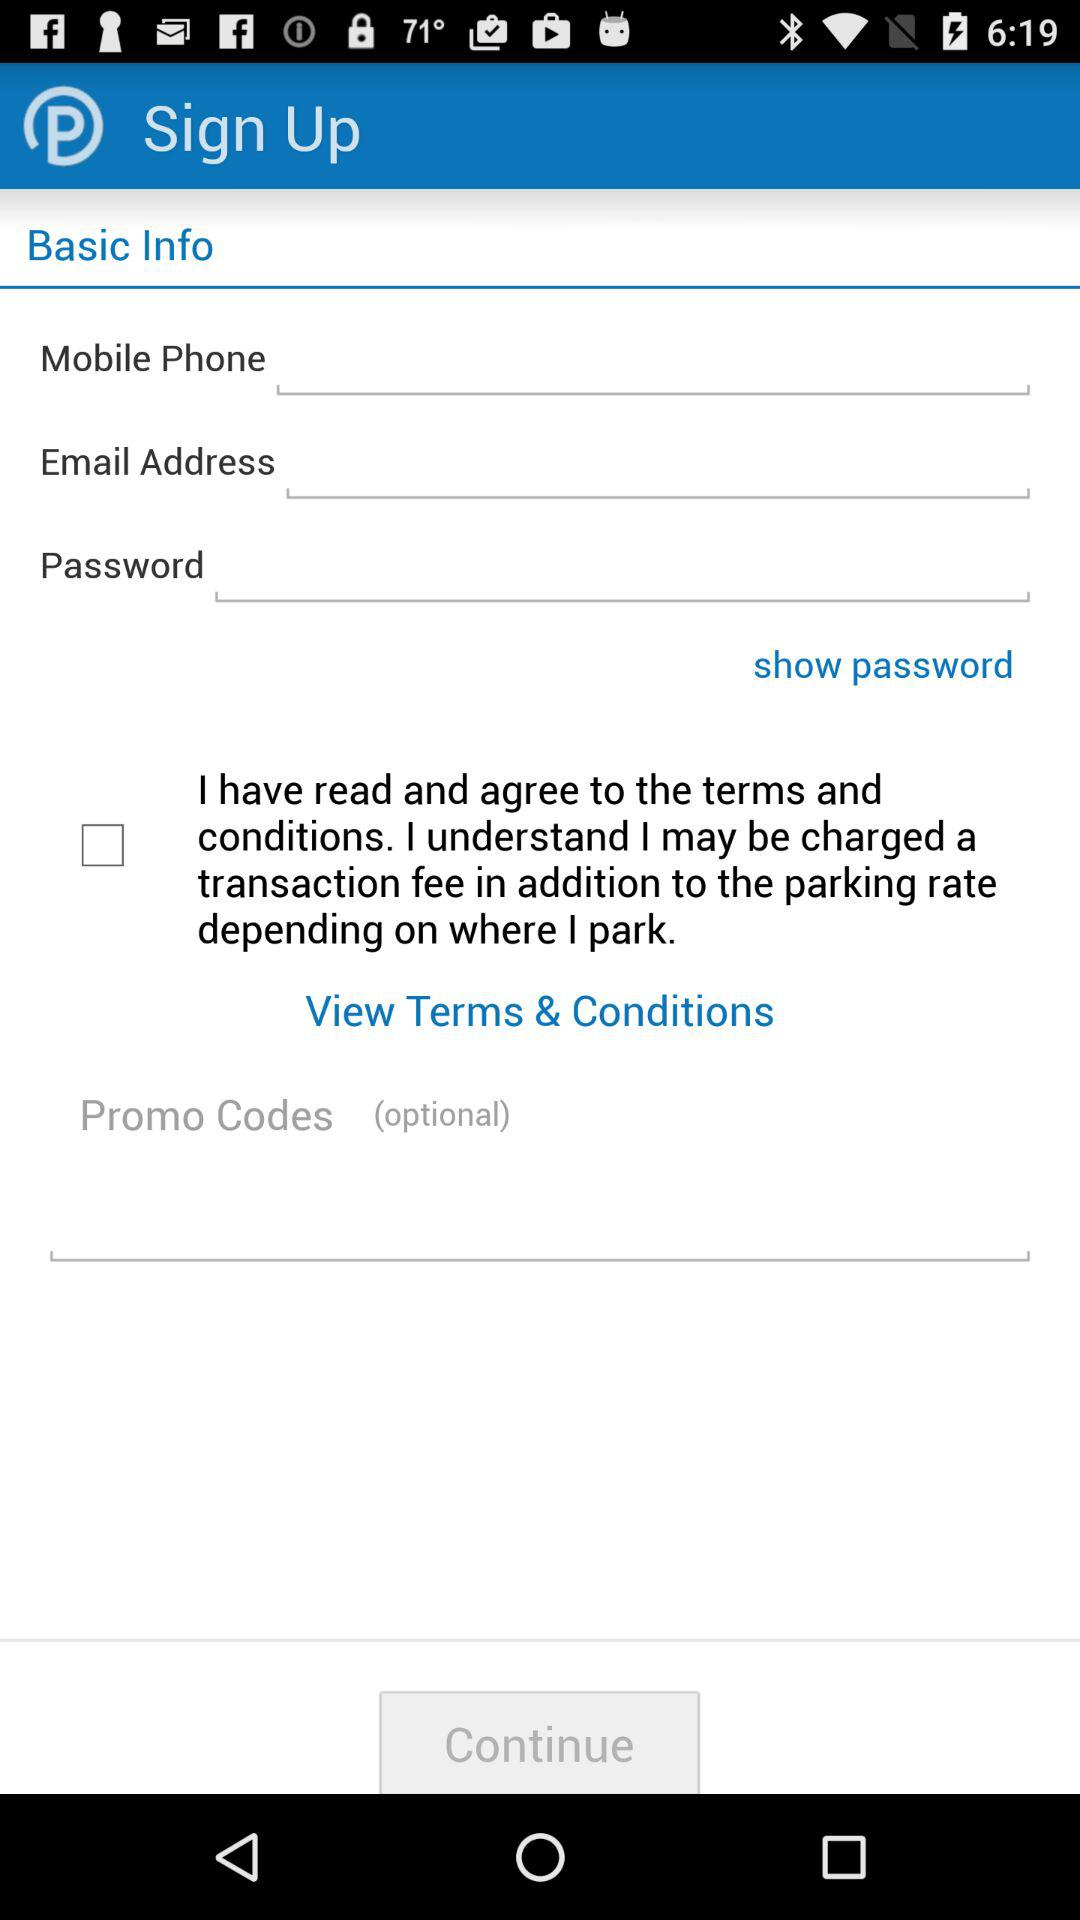How many characters are required to create a password?
When the provided information is insufficient, respond with <no answer>. <no answer> 